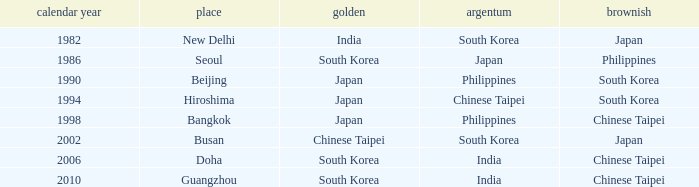Which Location has a Silver of japan? Seoul. 